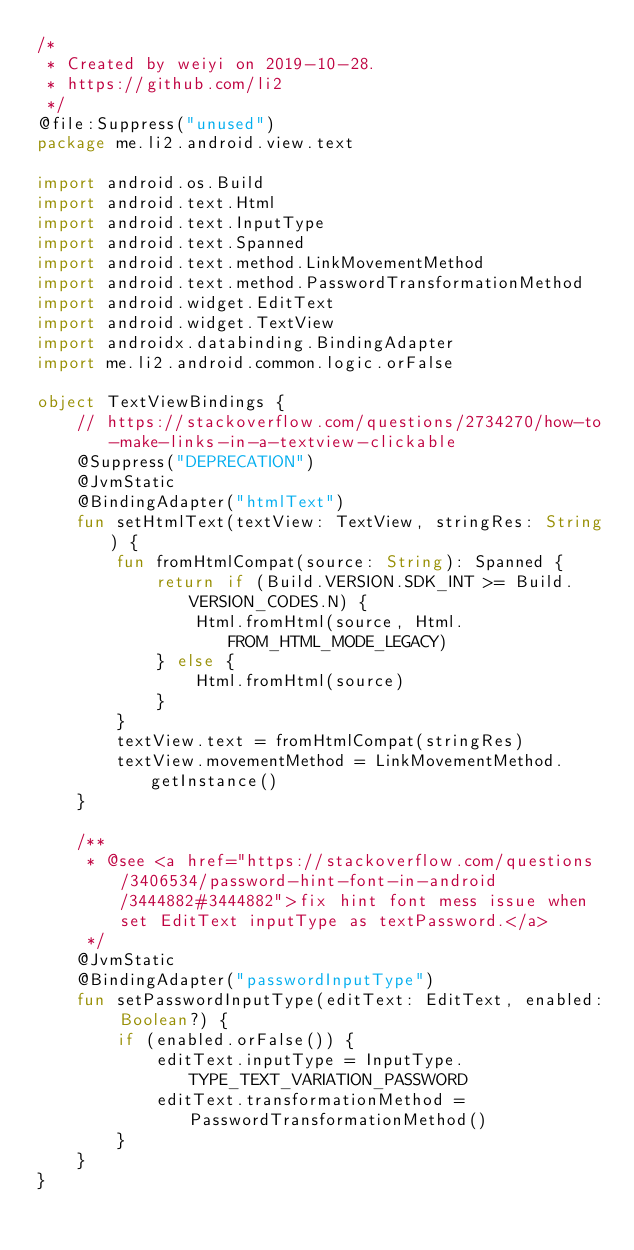<code> <loc_0><loc_0><loc_500><loc_500><_Kotlin_>/*
 * Created by weiyi on 2019-10-28.
 * https://github.com/li2
 */
@file:Suppress("unused")
package me.li2.android.view.text

import android.os.Build
import android.text.Html
import android.text.InputType
import android.text.Spanned
import android.text.method.LinkMovementMethod
import android.text.method.PasswordTransformationMethod
import android.widget.EditText
import android.widget.TextView
import androidx.databinding.BindingAdapter
import me.li2.android.common.logic.orFalse

object TextViewBindings {
    // https://stackoverflow.com/questions/2734270/how-to-make-links-in-a-textview-clickable
    @Suppress("DEPRECATION")
    @JvmStatic
    @BindingAdapter("htmlText")
    fun setHtmlText(textView: TextView, stringRes: String) {
        fun fromHtmlCompat(source: String): Spanned {
            return if (Build.VERSION.SDK_INT >= Build.VERSION_CODES.N) {
                Html.fromHtml(source, Html.FROM_HTML_MODE_LEGACY)
            } else {
                Html.fromHtml(source)
            }
        }
        textView.text = fromHtmlCompat(stringRes)
        textView.movementMethod = LinkMovementMethod.getInstance()
    }

    /**
     * @see <a href="https://stackoverflow.com/questions/3406534/password-hint-font-in-android/3444882#3444882">fix hint font mess issue when set EditText inputType as textPassword.</a>
     */
    @JvmStatic
    @BindingAdapter("passwordInputType")
    fun setPasswordInputType(editText: EditText, enabled: Boolean?) {
        if (enabled.orFalse()) {
            editText.inputType = InputType.TYPE_TEXT_VARIATION_PASSWORD
            editText.transformationMethod = PasswordTransformationMethod()
        }
    }
}
</code> 